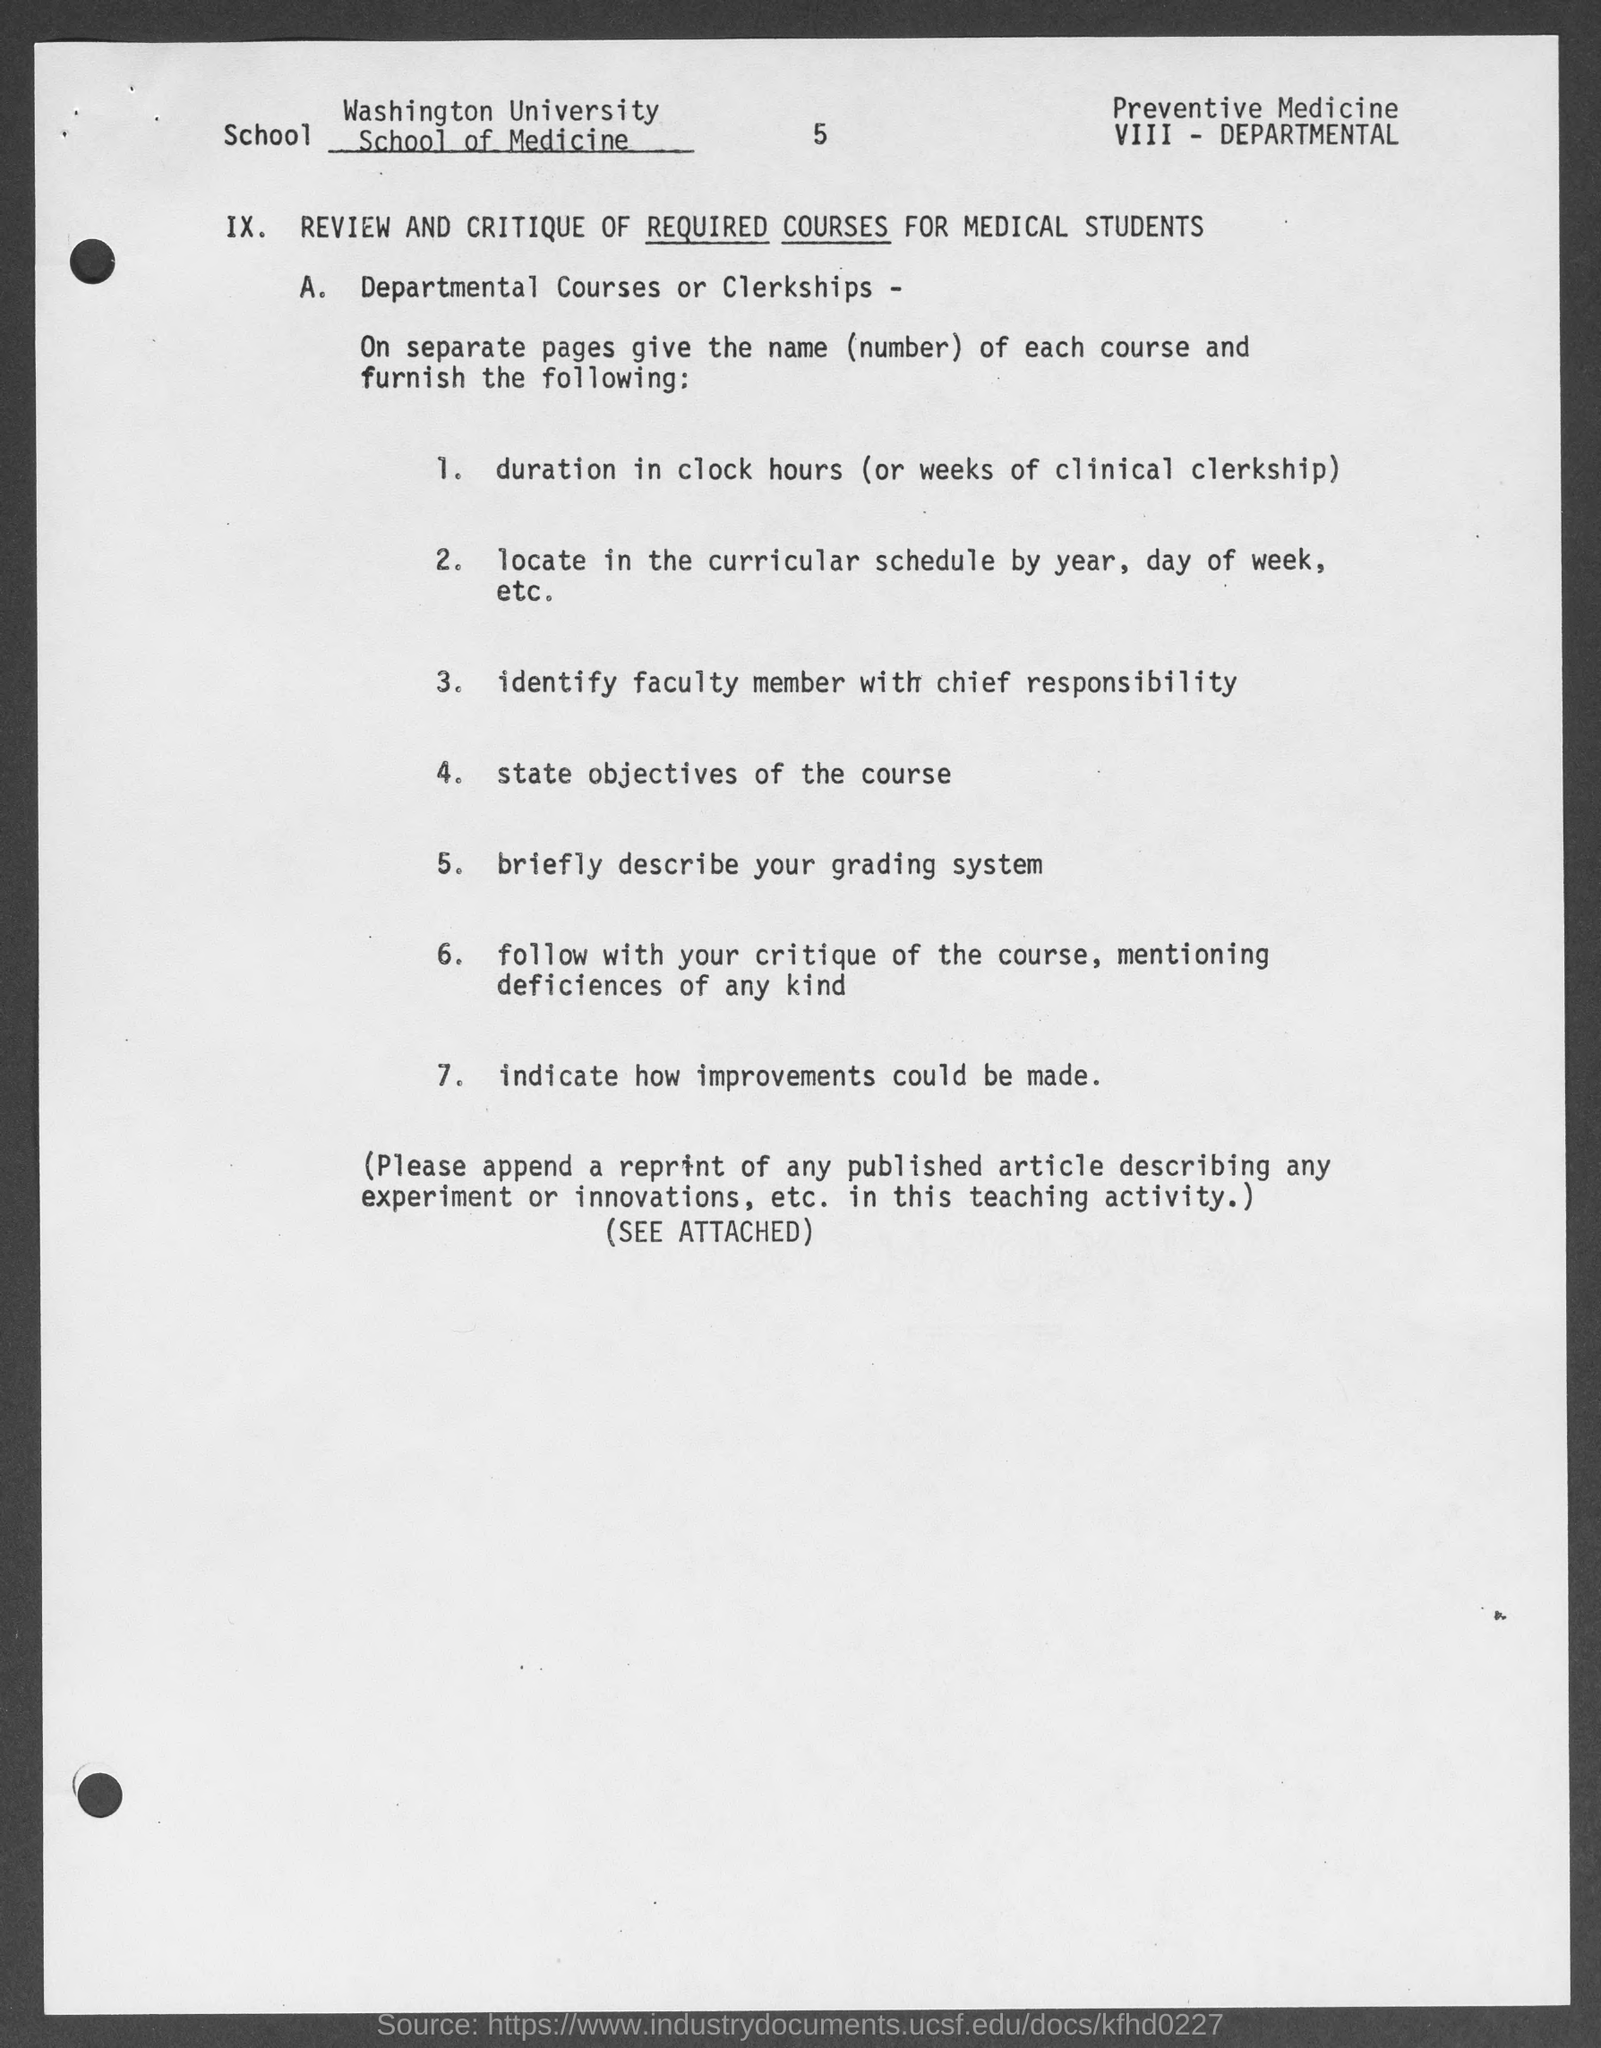Highlight a few significant elements in this photo. The page number mentioned in this document is 5. The Washington University School of Medicine is mentioned in the document. 